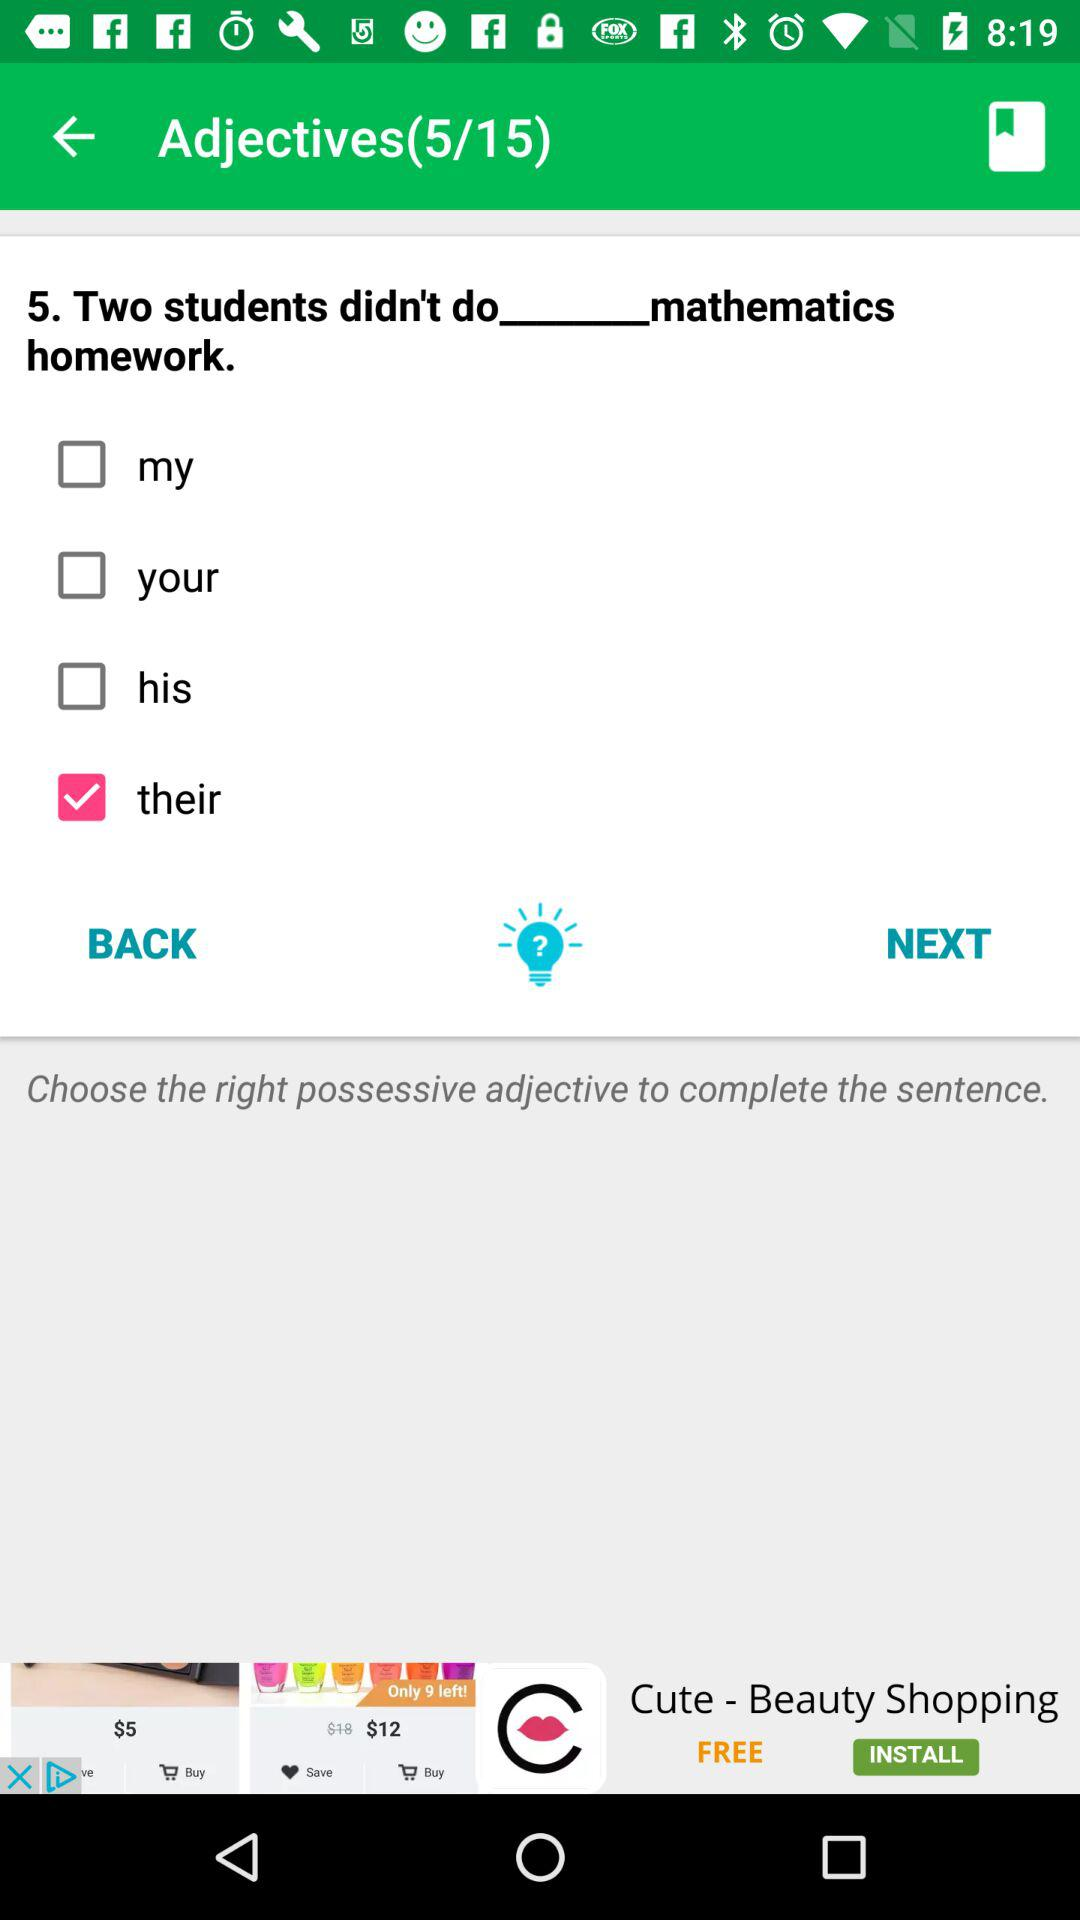How many questions are available? The number of available questions is 15. 